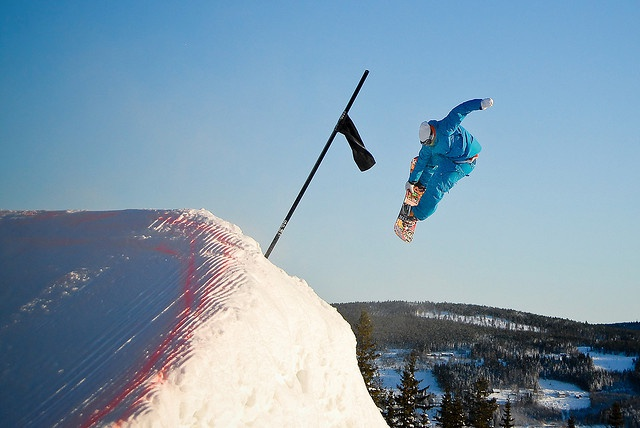Describe the objects in this image and their specific colors. I can see people in teal, blue, and navy tones and snowboard in teal, darkgray, gray, black, and lightpink tones in this image. 